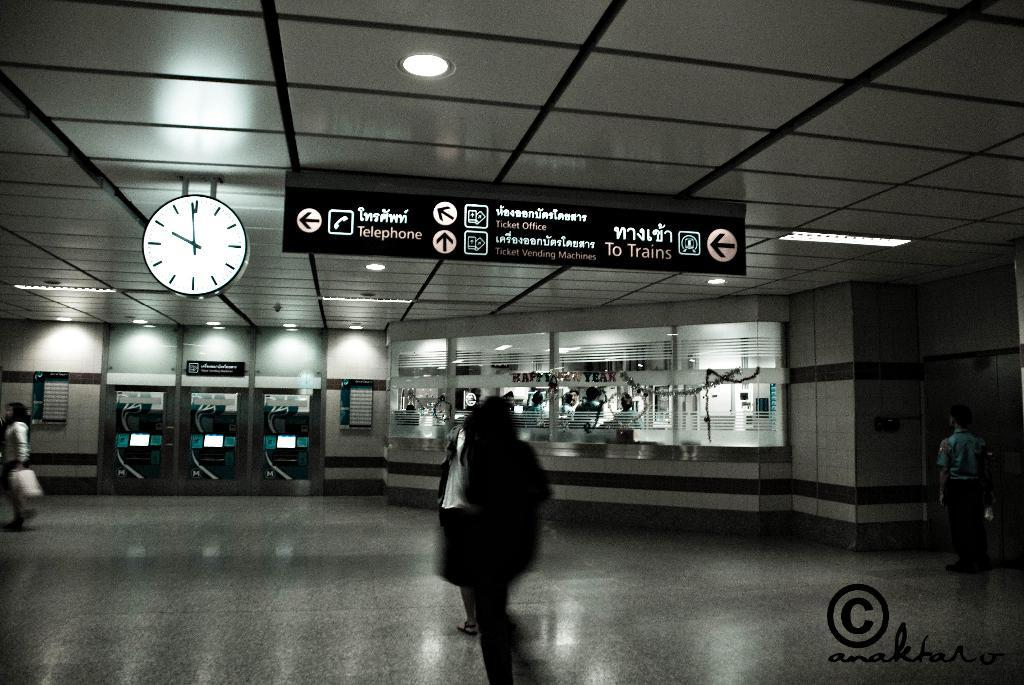What are the people in the image doing? The people in the image are walking. What structure can be seen in the image? There is a counter in the image. What objects are at the top of the image? There is a clock, a board, and lights at the top of the image. What type of knowledge is being discussed by the committee in the image? There is no committee present in the image, and therefore no discussion of knowledge can be observed. Is it raining in the image? The provided facts do not mention any weather conditions, so it cannot be determined if it is raining in the image. 